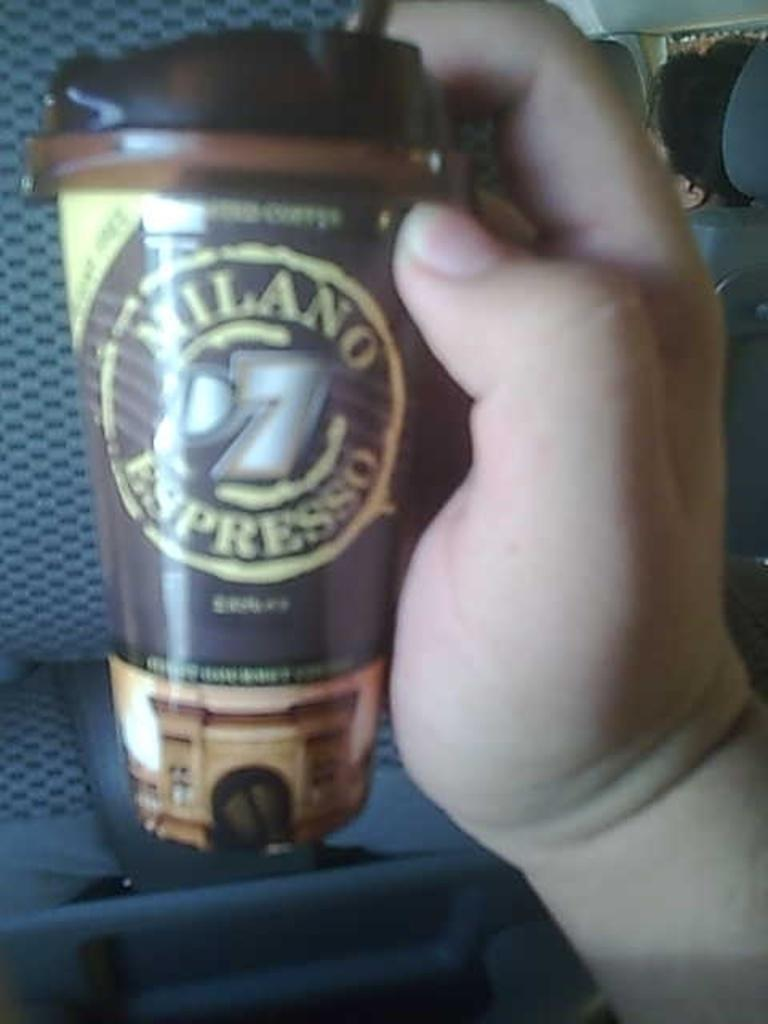What is the person's hand holding in the image? There is a person's hand holding a cup in the image. Can you describe any other part of the person's body visible in the image? There appears to be a head of a person in the right corner of the image. What type of van can be seen in the image? There is no van present in the image. How many things are visible in the image? It is not possible to determine the exact number of things visible in the image without additional information. 